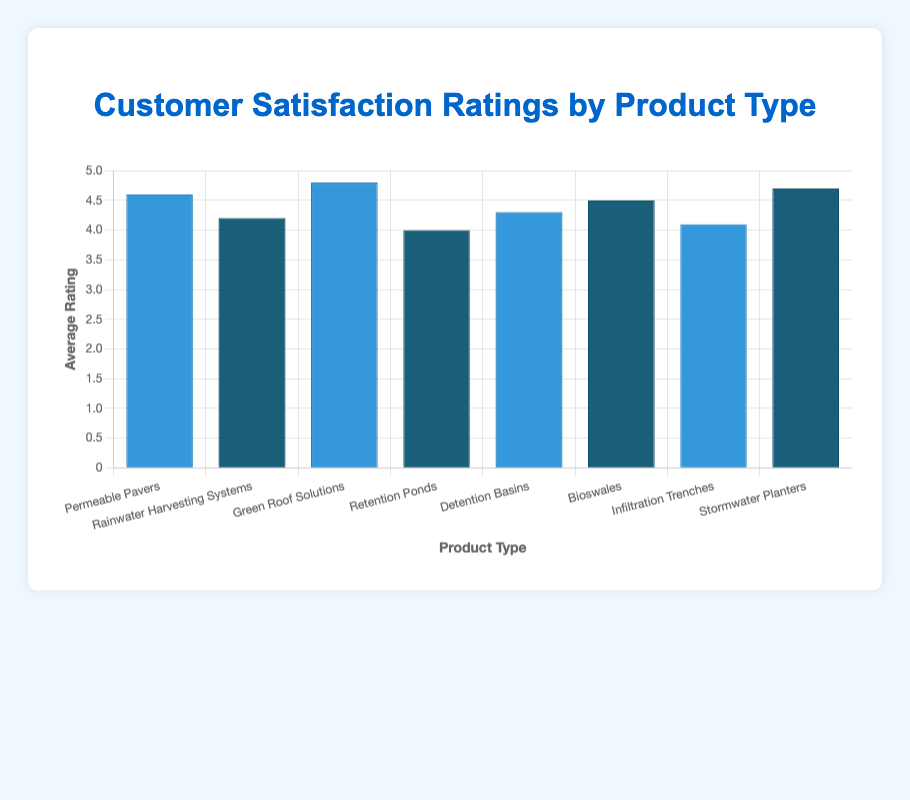What is the difference in average rating between Green Roof Solutions and Retention Ponds? Green Roof Solutions has an average rating of 4.8, while Retention Ponds have a rating of 4.0. The difference is 4.8 - 4.0 = 0.8.
Answer: 0.8 Which product type has the highest average rating? By looking at the heights of the bars, Green Roof Solutions has the highest average rating of 4.8.
Answer: Green Roof Solutions How does the average rating of Bioswales compare to that of Detention Basins? The average rating of Bioswales is 4.5, which is higher than Detention Basins with an average rating of 4.3.
Answer: Bioswales are higher What is the sum of the average ratings for Permeable Pavers and Stormwater Planters? The average rating for Permeable Pavers is 4.6, and for Stormwater Planters, it is 4.7. The sum is 4.6 + 4.7 = 9.3.
Answer: 9.3 What is the median average rating of all the product types? To find the median, first list all the average ratings in ascending order: 4.0, 4.1, 4.2, 4.3, 4.5, 4.6, 4.7, 4.8. The median is the average of the 4th and 5th ratings: (4.3 + 4.5) / 2 = 4.4.
Answer: 4.4 Which product types are depicted using dark blue bars? The dark blue bars correspond to Rainwater Harvesting Systems, Retention Ponds, Bioswales, and Stormwater Planters.
Answer: Rainwater Harvesting Systems, Retention Ponds, Bioswales, Stormwater Planters What is the average rating for all product types combined? Adding all average ratings: 4.6 + 4.2 + 4.8 + 4.0 + 4.3 + 4.5 + 4.1 + 4.7 = 35.2. Dividing by the number of product types (8) gives 35.2 / 8 = 4.4.
Answer: 4.4 Which product types have an average rating greater than 4.5? From the ratings, Green Roof Solutions (4.8), Stormwater Planters (4.7), and Permeable Pavers (4.6) all have ratings greater than 4.5.
Answer: Green Roof Solutions, Stormwater Planters, Permeable Pavers 